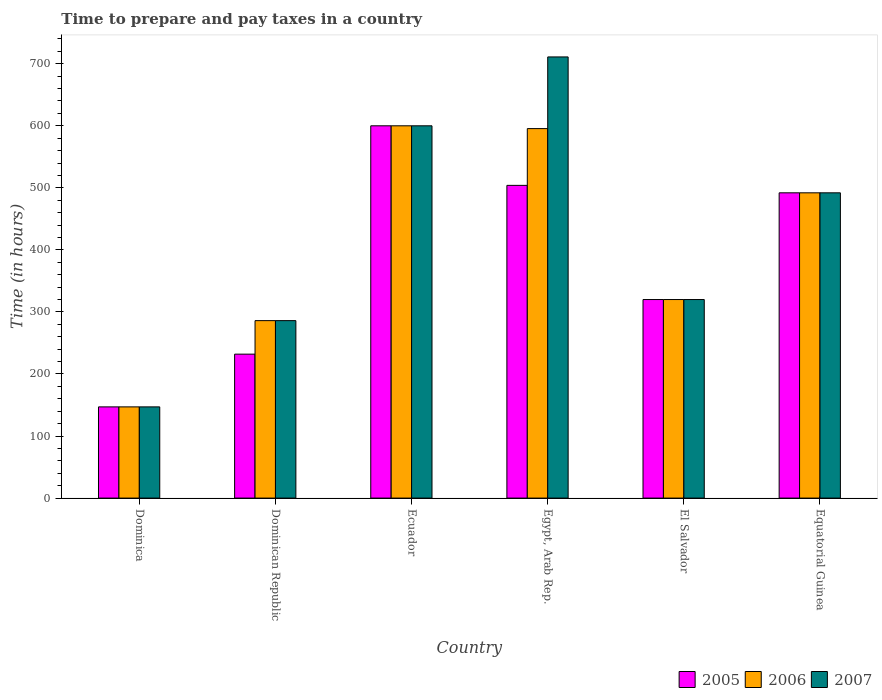How many bars are there on the 1st tick from the left?
Make the answer very short. 3. What is the label of the 6th group of bars from the left?
Offer a terse response. Equatorial Guinea. What is the number of hours required to prepare and pay taxes in 2007 in Egypt, Arab Rep.?
Make the answer very short. 711. Across all countries, what is the maximum number of hours required to prepare and pay taxes in 2005?
Ensure brevity in your answer.  600. Across all countries, what is the minimum number of hours required to prepare and pay taxes in 2005?
Keep it short and to the point. 147. In which country was the number of hours required to prepare and pay taxes in 2007 maximum?
Offer a very short reply. Egypt, Arab Rep. In which country was the number of hours required to prepare and pay taxes in 2007 minimum?
Keep it short and to the point. Dominica. What is the total number of hours required to prepare and pay taxes in 2006 in the graph?
Provide a short and direct response. 2440.5. What is the difference between the number of hours required to prepare and pay taxes in 2005 in Dominica and the number of hours required to prepare and pay taxes in 2007 in Equatorial Guinea?
Your answer should be very brief. -345. What is the average number of hours required to prepare and pay taxes in 2006 per country?
Offer a terse response. 406.75. What is the difference between the number of hours required to prepare and pay taxes of/in 2007 and number of hours required to prepare and pay taxes of/in 2006 in Dominican Republic?
Your answer should be very brief. 0. What is the ratio of the number of hours required to prepare and pay taxes in 2007 in Ecuador to that in El Salvador?
Provide a short and direct response. 1.88. Is the number of hours required to prepare and pay taxes in 2006 in Dominica less than that in Dominican Republic?
Offer a terse response. Yes. What is the difference between the highest and the second highest number of hours required to prepare and pay taxes in 2005?
Your response must be concise. 96. What is the difference between the highest and the lowest number of hours required to prepare and pay taxes in 2006?
Your response must be concise. 453. Is the sum of the number of hours required to prepare and pay taxes in 2007 in Dominica and Egypt, Arab Rep. greater than the maximum number of hours required to prepare and pay taxes in 2005 across all countries?
Keep it short and to the point. Yes. What does the 3rd bar from the right in Ecuador represents?
Offer a terse response. 2005. How many bars are there?
Your answer should be compact. 18. What is the difference between two consecutive major ticks on the Y-axis?
Give a very brief answer. 100. Are the values on the major ticks of Y-axis written in scientific E-notation?
Offer a terse response. No. Does the graph contain any zero values?
Keep it short and to the point. No. Does the graph contain grids?
Your answer should be very brief. No. Where does the legend appear in the graph?
Give a very brief answer. Bottom right. How many legend labels are there?
Your response must be concise. 3. How are the legend labels stacked?
Provide a succinct answer. Horizontal. What is the title of the graph?
Offer a terse response. Time to prepare and pay taxes in a country. What is the label or title of the Y-axis?
Ensure brevity in your answer.  Time (in hours). What is the Time (in hours) in 2005 in Dominica?
Offer a very short reply. 147. What is the Time (in hours) of 2006 in Dominica?
Ensure brevity in your answer.  147. What is the Time (in hours) of 2007 in Dominica?
Provide a succinct answer. 147. What is the Time (in hours) in 2005 in Dominican Republic?
Offer a terse response. 232. What is the Time (in hours) of 2006 in Dominican Republic?
Your answer should be very brief. 286. What is the Time (in hours) of 2007 in Dominican Republic?
Provide a succinct answer. 286. What is the Time (in hours) of 2005 in Ecuador?
Make the answer very short. 600. What is the Time (in hours) in 2006 in Ecuador?
Keep it short and to the point. 600. What is the Time (in hours) in 2007 in Ecuador?
Your answer should be compact. 600. What is the Time (in hours) in 2005 in Egypt, Arab Rep.?
Ensure brevity in your answer.  504. What is the Time (in hours) in 2006 in Egypt, Arab Rep.?
Make the answer very short. 595.5. What is the Time (in hours) of 2007 in Egypt, Arab Rep.?
Provide a succinct answer. 711. What is the Time (in hours) of 2005 in El Salvador?
Provide a succinct answer. 320. What is the Time (in hours) in 2006 in El Salvador?
Ensure brevity in your answer.  320. What is the Time (in hours) of 2007 in El Salvador?
Make the answer very short. 320. What is the Time (in hours) in 2005 in Equatorial Guinea?
Make the answer very short. 492. What is the Time (in hours) of 2006 in Equatorial Guinea?
Your response must be concise. 492. What is the Time (in hours) in 2007 in Equatorial Guinea?
Ensure brevity in your answer.  492. Across all countries, what is the maximum Time (in hours) in 2005?
Provide a short and direct response. 600. Across all countries, what is the maximum Time (in hours) of 2006?
Offer a very short reply. 600. Across all countries, what is the maximum Time (in hours) of 2007?
Offer a terse response. 711. Across all countries, what is the minimum Time (in hours) of 2005?
Keep it short and to the point. 147. Across all countries, what is the minimum Time (in hours) in 2006?
Your answer should be compact. 147. Across all countries, what is the minimum Time (in hours) in 2007?
Your answer should be compact. 147. What is the total Time (in hours) of 2005 in the graph?
Make the answer very short. 2295. What is the total Time (in hours) of 2006 in the graph?
Your answer should be compact. 2440.5. What is the total Time (in hours) of 2007 in the graph?
Offer a terse response. 2556. What is the difference between the Time (in hours) in 2005 in Dominica and that in Dominican Republic?
Offer a very short reply. -85. What is the difference between the Time (in hours) in 2006 in Dominica and that in Dominican Republic?
Provide a succinct answer. -139. What is the difference between the Time (in hours) of 2007 in Dominica and that in Dominican Republic?
Give a very brief answer. -139. What is the difference between the Time (in hours) of 2005 in Dominica and that in Ecuador?
Your answer should be very brief. -453. What is the difference between the Time (in hours) of 2006 in Dominica and that in Ecuador?
Offer a very short reply. -453. What is the difference between the Time (in hours) of 2007 in Dominica and that in Ecuador?
Your answer should be very brief. -453. What is the difference between the Time (in hours) in 2005 in Dominica and that in Egypt, Arab Rep.?
Your response must be concise. -357. What is the difference between the Time (in hours) of 2006 in Dominica and that in Egypt, Arab Rep.?
Your answer should be very brief. -448.5. What is the difference between the Time (in hours) of 2007 in Dominica and that in Egypt, Arab Rep.?
Provide a succinct answer. -564. What is the difference between the Time (in hours) of 2005 in Dominica and that in El Salvador?
Ensure brevity in your answer.  -173. What is the difference between the Time (in hours) in 2006 in Dominica and that in El Salvador?
Make the answer very short. -173. What is the difference between the Time (in hours) in 2007 in Dominica and that in El Salvador?
Ensure brevity in your answer.  -173. What is the difference between the Time (in hours) in 2005 in Dominica and that in Equatorial Guinea?
Keep it short and to the point. -345. What is the difference between the Time (in hours) of 2006 in Dominica and that in Equatorial Guinea?
Provide a succinct answer. -345. What is the difference between the Time (in hours) in 2007 in Dominica and that in Equatorial Guinea?
Give a very brief answer. -345. What is the difference between the Time (in hours) of 2005 in Dominican Republic and that in Ecuador?
Keep it short and to the point. -368. What is the difference between the Time (in hours) in 2006 in Dominican Republic and that in Ecuador?
Your answer should be compact. -314. What is the difference between the Time (in hours) of 2007 in Dominican Republic and that in Ecuador?
Make the answer very short. -314. What is the difference between the Time (in hours) of 2005 in Dominican Republic and that in Egypt, Arab Rep.?
Give a very brief answer. -272. What is the difference between the Time (in hours) of 2006 in Dominican Republic and that in Egypt, Arab Rep.?
Make the answer very short. -309.5. What is the difference between the Time (in hours) of 2007 in Dominican Republic and that in Egypt, Arab Rep.?
Keep it short and to the point. -425. What is the difference between the Time (in hours) of 2005 in Dominican Republic and that in El Salvador?
Offer a terse response. -88. What is the difference between the Time (in hours) of 2006 in Dominican Republic and that in El Salvador?
Ensure brevity in your answer.  -34. What is the difference between the Time (in hours) of 2007 in Dominican Republic and that in El Salvador?
Provide a short and direct response. -34. What is the difference between the Time (in hours) in 2005 in Dominican Republic and that in Equatorial Guinea?
Ensure brevity in your answer.  -260. What is the difference between the Time (in hours) in 2006 in Dominican Republic and that in Equatorial Guinea?
Your answer should be compact. -206. What is the difference between the Time (in hours) in 2007 in Dominican Republic and that in Equatorial Guinea?
Make the answer very short. -206. What is the difference between the Time (in hours) in 2005 in Ecuador and that in Egypt, Arab Rep.?
Your answer should be very brief. 96. What is the difference between the Time (in hours) in 2006 in Ecuador and that in Egypt, Arab Rep.?
Provide a succinct answer. 4.5. What is the difference between the Time (in hours) of 2007 in Ecuador and that in Egypt, Arab Rep.?
Your answer should be very brief. -111. What is the difference between the Time (in hours) in 2005 in Ecuador and that in El Salvador?
Provide a succinct answer. 280. What is the difference between the Time (in hours) of 2006 in Ecuador and that in El Salvador?
Provide a succinct answer. 280. What is the difference between the Time (in hours) in 2007 in Ecuador and that in El Salvador?
Keep it short and to the point. 280. What is the difference between the Time (in hours) of 2005 in Ecuador and that in Equatorial Guinea?
Your answer should be compact. 108. What is the difference between the Time (in hours) in 2006 in Ecuador and that in Equatorial Guinea?
Offer a very short reply. 108. What is the difference between the Time (in hours) of 2007 in Ecuador and that in Equatorial Guinea?
Give a very brief answer. 108. What is the difference between the Time (in hours) of 2005 in Egypt, Arab Rep. and that in El Salvador?
Your answer should be compact. 184. What is the difference between the Time (in hours) of 2006 in Egypt, Arab Rep. and that in El Salvador?
Provide a short and direct response. 275.5. What is the difference between the Time (in hours) of 2007 in Egypt, Arab Rep. and that in El Salvador?
Offer a very short reply. 391. What is the difference between the Time (in hours) of 2005 in Egypt, Arab Rep. and that in Equatorial Guinea?
Your response must be concise. 12. What is the difference between the Time (in hours) in 2006 in Egypt, Arab Rep. and that in Equatorial Guinea?
Your answer should be compact. 103.5. What is the difference between the Time (in hours) in 2007 in Egypt, Arab Rep. and that in Equatorial Guinea?
Keep it short and to the point. 219. What is the difference between the Time (in hours) in 2005 in El Salvador and that in Equatorial Guinea?
Offer a very short reply. -172. What is the difference between the Time (in hours) in 2006 in El Salvador and that in Equatorial Guinea?
Provide a succinct answer. -172. What is the difference between the Time (in hours) of 2007 in El Salvador and that in Equatorial Guinea?
Provide a succinct answer. -172. What is the difference between the Time (in hours) in 2005 in Dominica and the Time (in hours) in 2006 in Dominican Republic?
Your answer should be very brief. -139. What is the difference between the Time (in hours) of 2005 in Dominica and the Time (in hours) of 2007 in Dominican Republic?
Provide a succinct answer. -139. What is the difference between the Time (in hours) of 2006 in Dominica and the Time (in hours) of 2007 in Dominican Republic?
Ensure brevity in your answer.  -139. What is the difference between the Time (in hours) in 2005 in Dominica and the Time (in hours) in 2006 in Ecuador?
Keep it short and to the point. -453. What is the difference between the Time (in hours) in 2005 in Dominica and the Time (in hours) in 2007 in Ecuador?
Provide a succinct answer. -453. What is the difference between the Time (in hours) in 2006 in Dominica and the Time (in hours) in 2007 in Ecuador?
Your answer should be compact. -453. What is the difference between the Time (in hours) in 2005 in Dominica and the Time (in hours) in 2006 in Egypt, Arab Rep.?
Offer a terse response. -448.5. What is the difference between the Time (in hours) in 2005 in Dominica and the Time (in hours) in 2007 in Egypt, Arab Rep.?
Offer a very short reply. -564. What is the difference between the Time (in hours) in 2006 in Dominica and the Time (in hours) in 2007 in Egypt, Arab Rep.?
Provide a short and direct response. -564. What is the difference between the Time (in hours) of 2005 in Dominica and the Time (in hours) of 2006 in El Salvador?
Provide a short and direct response. -173. What is the difference between the Time (in hours) in 2005 in Dominica and the Time (in hours) in 2007 in El Salvador?
Offer a very short reply. -173. What is the difference between the Time (in hours) of 2006 in Dominica and the Time (in hours) of 2007 in El Salvador?
Your answer should be compact. -173. What is the difference between the Time (in hours) of 2005 in Dominica and the Time (in hours) of 2006 in Equatorial Guinea?
Your answer should be compact. -345. What is the difference between the Time (in hours) in 2005 in Dominica and the Time (in hours) in 2007 in Equatorial Guinea?
Keep it short and to the point. -345. What is the difference between the Time (in hours) of 2006 in Dominica and the Time (in hours) of 2007 in Equatorial Guinea?
Your answer should be very brief. -345. What is the difference between the Time (in hours) of 2005 in Dominican Republic and the Time (in hours) of 2006 in Ecuador?
Offer a very short reply. -368. What is the difference between the Time (in hours) in 2005 in Dominican Republic and the Time (in hours) in 2007 in Ecuador?
Your answer should be compact. -368. What is the difference between the Time (in hours) in 2006 in Dominican Republic and the Time (in hours) in 2007 in Ecuador?
Your answer should be very brief. -314. What is the difference between the Time (in hours) of 2005 in Dominican Republic and the Time (in hours) of 2006 in Egypt, Arab Rep.?
Offer a terse response. -363.5. What is the difference between the Time (in hours) in 2005 in Dominican Republic and the Time (in hours) in 2007 in Egypt, Arab Rep.?
Your answer should be very brief. -479. What is the difference between the Time (in hours) of 2006 in Dominican Republic and the Time (in hours) of 2007 in Egypt, Arab Rep.?
Make the answer very short. -425. What is the difference between the Time (in hours) of 2005 in Dominican Republic and the Time (in hours) of 2006 in El Salvador?
Make the answer very short. -88. What is the difference between the Time (in hours) in 2005 in Dominican Republic and the Time (in hours) in 2007 in El Salvador?
Give a very brief answer. -88. What is the difference between the Time (in hours) in 2006 in Dominican Republic and the Time (in hours) in 2007 in El Salvador?
Your response must be concise. -34. What is the difference between the Time (in hours) in 2005 in Dominican Republic and the Time (in hours) in 2006 in Equatorial Guinea?
Keep it short and to the point. -260. What is the difference between the Time (in hours) in 2005 in Dominican Republic and the Time (in hours) in 2007 in Equatorial Guinea?
Provide a short and direct response. -260. What is the difference between the Time (in hours) of 2006 in Dominican Republic and the Time (in hours) of 2007 in Equatorial Guinea?
Keep it short and to the point. -206. What is the difference between the Time (in hours) in 2005 in Ecuador and the Time (in hours) in 2007 in Egypt, Arab Rep.?
Your response must be concise. -111. What is the difference between the Time (in hours) of 2006 in Ecuador and the Time (in hours) of 2007 in Egypt, Arab Rep.?
Provide a succinct answer. -111. What is the difference between the Time (in hours) in 2005 in Ecuador and the Time (in hours) in 2006 in El Salvador?
Your answer should be compact. 280. What is the difference between the Time (in hours) of 2005 in Ecuador and the Time (in hours) of 2007 in El Salvador?
Provide a succinct answer. 280. What is the difference between the Time (in hours) in 2006 in Ecuador and the Time (in hours) in 2007 in El Salvador?
Ensure brevity in your answer.  280. What is the difference between the Time (in hours) of 2005 in Ecuador and the Time (in hours) of 2006 in Equatorial Guinea?
Provide a short and direct response. 108. What is the difference between the Time (in hours) of 2005 in Ecuador and the Time (in hours) of 2007 in Equatorial Guinea?
Keep it short and to the point. 108. What is the difference between the Time (in hours) in 2006 in Ecuador and the Time (in hours) in 2007 in Equatorial Guinea?
Ensure brevity in your answer.  108. What is the difference between the Time (in hours) in 2005 in Egypt, Arab Rep. and the Time (in hours) in 2006 in El Salvador?
Provide a short and direct response. 184. What is the difference between the Time (in hours) in 2005 in Egypt, Arab Rep. and the Time (in hours) in 2007 in El Salvador?
Make the answer very short. 184. What is the difference between the Time (in hours) in 2006 in Egypt, Arab Rep. and the Time (in hours) in 2007 in El Salvador?
Keep it short and to the point. 275.5. What is the difference between the Time (in hours) of 2006 in Egypt, Arab Rep. and the Time (in hours) of 2007 in Equatorial Guinea?
Give a very brief answer. 103.5. What is the difference between the Time (in hours) in 2005 in El Salvador and the Time (in hours) in 2006 in Equatorial Guinea?
Provide a succinct answer. -172. What is the difference between the Time (in hours) of 2005 in El Salvador and the Time (in hours) of 2007 in Equatorial Guinea?
Offer a very short reply. -172. What is the difference between the Time (in hours) in 2006 in El Salvador and the Time (in hours) in 2007 in Equatorial Guinea?
Your response must be concise. -172. What is the average Time (in hours) of 2005 per country?
Provide a succinct answer. 382.5. What is the average Time (in hours) of 2006 per country?
Your answer should be very brief. 406.75. What is the average Time (in hours) in 2007 per country?
Give a very brief answer. 426. What is the difference between the Time (in hours) of 2006 and Time (in hours) of 2007 in Dominica?
Ensure brevity in your answer.  0. What is the difference between the Time (in hours) of 2005 and Time (in hours) of 2006 in Dominican Republic?
Give a very brief answer. -54. What is the difference between the Time (in hours) of 2005 and Time (in hours) of 2007 in Dominican Republic?
Ensure brevity in your answer.  -54. What is the difference between the Time (in hours) in 2006 and Time (in hours) in 2007 in Dominican Republic?
Provide a succinct answer. 0. What is the difference between the Time (in hours) in 2005 and Time (in hours) in 2006 in Ecuador?
Provide a succinct answer. 0. What is the difference between the Time (in hours) in 2006 and Time (in hours) in 2007 in Ecuador?
Ensure brevity in your answer.  0. What is the difference between the Time (in hours) of 2005 and Time (in hours) of 2006 in Egypt, Arab Rep.?
Provide a short and direct response. -91.5. What is the difference between the Time (in hours) in 2005 and Time (in hours) in 2007 in Egypt, Arab Rep.?
Keep it short and to the point. -207. What is the difference between the Time (in hours) of 2006 and Time (in hours) of 2007 in Egypt, Arab Rep.?
Provide a short and direct response. -115.5. What is the difference between the Time (in hours) of 2005 and Time (in hours) of 2006 in El Salvador?
Your answer should be compact. 0. What is the difference between the Time (in hours) in 2006 and Time (in hours) in 2007 in El Salvador?
Your answer should be very brief. 0. What is the difference between the Time (in hours) of 2005 and Time (in hours) of 2006 in Equatorial Guinea?
Offer a very short reply. 0. What is the difference between the Time (in hours) in 2006 and Time (in hours) in 2007 in Equatorial Guinea?
Provide a short and direct response. 0. What is the ratio of the Time (in hours) of 2005 in Dominica to that in Dominican Republic?
Provide a succinct answer. 0.63. What is the ratio of the Time (in hours) of 2006 in Dominica to that in Dominican Republic?
Offer a terse response. 0.51. What is the ratio of the Time (in hours) of 2007 in Dominica to that in Dominican Republic?
Provide a succinct answer. 0.51. What is the ratio of the Time (in hours) in 2005 in Dominica to that in Ecuador?
Your answer should be compact. 0.24. What is the ratio of the Time (in hours) of 2006 in Dominica to that in Ecuador?
Make the answer very short. 0.24. What is the ratio of the Time (in hours) in 2007 in Dominica to that in Ecuador?
Give a very brief answer. 0.24. What is the ratio of the Time (in hours) in 2005 in Dominica to that in Egypt, Arab Rep.?
Give a very brief answer. 0.29. What is the ratio of the Time (in hours) of 2006 in Dominica to that in Egypt, Arab Rep.?
Offer a terse response. 0.25. What is the ratio of the Time (in hours) of 2007 in Dominica to that in Egypt, Arab Rep.?
Your answer should be very brief. 0.21. What is the ratio of the Time (in hours) of 2005 in Dominica to that in El Salvador?
Give a very brief answer. 0.46. What is the ratio of the Time (in hours) in 2006 in Dominica to that in El Salvador?
Make the answer very short. 0.46. What is the ratio of the Time (in hours) in 2007 in Dominica to that in El Salvador?
Make the answer very short. 0.46. What is the ratio of the Time (in hours) of 2005 in Dominica to that in Equatorial Guinea?
Offer a very short reply. 0.3. What is the ratio of the Time (in hours) in 2006 in Dominica to that in Equatorial Guinea?
Offer a very short reply. 0.3. What is the ratio of the Time (in hours) in 2007 in Dominica to that in Equatorial Guinea?
Your answer should be compact. 0.3. What is the ratio of the Time (in hours) in 2005 in Dominican Republic to that in Ecuador?
Your answer should be very brief. 0.39. What is the ratio of the Time (in hours) in 2006 in Dominican Republic to that in Ecuador?
Make the answer very short. 0.48. What is the ratio of the Time (in hours) in 2007 in Dominican Republic to that in Ecuador?
Your answer should be very brief. 0.48. What is the ratio of the Time (in hours) of 2005 in Dominican Republic to that in Egypt, Arab Rep.?
Provide a short and direct response. 0.46. What is the ratio of the Time (in hours) in 2006 in Dominican Republic to that in Egypt, Arab Rep.?
Ensure brevity in your answer.  0.48. What is the ratio of the Time (in hours) in 2007 in Dominican Republic to that in Egypt, Arab Rep.?
Provide a short and direct response. 0.4. What is the ratio of the Time (in hours) of 2005 in Dominican Republic to that in El Salvador?
Offer a terse response. 0.72. What is the ratio of the Time (in hours) of 2006 in Dominican Republic to that in El Salvador?
Offer a very short reply. 0.89. What is the ratio of the Time (in hours) in 2007 in Dominican Republic to that in El Salvador?
Provide a succinct answer. 0.89. What is the ratio of the Time (in hours) of 2005 in Dominican Republic to that in Equatorial Guinea?
Your answer should be very brief. 0.47. What is the ratio of the Time (in hours) in 2006 in Dominican Republic to that in Equatorial Guinea?
Make the answer very short. 0.58. What is the ratio of the Time (in hours) of 2007 in Dominican Republic to that in Equatorial Guinea?
Give a very brief answer. 0.58. What is the ratio of the Time (in hours) in 2005 in Ecuador to that in Egypt, Arab Rep.?
Your answer should be compact. 1.19. What is the ratio of the Time (in hours) of 2006 in Ecuador to that in Egypt, Arab Rep.?
Ensure brevity in your answer.  1.01. What is the ratio of the Time (in hours) in 2007 in Ecuador to that in Egypt, Arab Rep.?
Your answer should be very brief. 0.84. What is the ratio of the Time (in hours) of 2005 in Ecuador to that in El Salvador?
Your response must be concise. 1.88. What is the ratio of the Time (in hours) of 2006 in Ecuador to that in El Salvador?
Offer a terse response. 1.88. What is the ratio of the Time (in hours) of 2007 in Ecuador to that in El Salvador?
Provide a succinct answer. 1.88. What is the ratio of the Time (in hours) in 2005 in Ecuador to that in Equatorial Guinea?
Your answer should be compact. 1.22. What is the ratio of the Time (in hours) in 2006 in Ecuador to that in Equatorial Guinea?
Provide a succinct answer. 1.22. What is the ratio of the Time (in hours) in 2007 in Ecuador to that in Equatorial Guinea?
Your answer should be compact. 1.22. What is the ratio of the Time (in hours) of 2005 in Egypt, Arab Rep. to that in El Salvador?
Offer a very short reply. 1.57. What is the ratio of the Time (in hours) in 2006 in Egypt, Arab Rep. to that in El Salvador?
Keep it short and to the point. 1.86. What is the ratio of the Time (in hours) of 2007 in Egypt, Arab Rep. to that in El Salvador?
Offer a very short reply. 2.22. What is the ratio of the Time (in hours) in 2005 in Egypt, Arab Rep. to that in Equatorial Guinea?
Make the answer very short. 1.02. What is the ratio of the Time (in hours) of 2006 in Egypt, Arab Rep. to that in Equatorial Guinea?
Provide a succinct answer. 1.21. What is the ratio of the Time (in hours) of 2007 in Egypt, Arab Rep. to that in Equatorial Guinea?
Offer a terse response. 1.45. What is the ratio of the Time (in hours) of 2005 in El Salvador to that in Equatorial Guinea?
Make the answer very short. 0.65. What is the ratio of the Time (in hours) of 2006 in El Salvador to that in Equatorial Guinea?
Your answer should be compact. 0.65. What is the ratio of the Time (in hours) of 2007 in El Salvador to that in Equatorial Guinea?
Your answer should be compact. 0.65. What is the difference between the highest and the second highest Time (in hours) in 2005?
Your answer should be very brief. 96. What is the difference between the highest and the second highest Time (in hours) in 2006?
Your response must be concise. 4.5. What is the difference between the highest and the second highest Time (in hours) in 2007?
Ensure brevity in your answer.  111. What is the difference between the highest and the lowest Time (in hours) of 2005?
Your response must be concise. 453. What is the difference between the highest and the lowest Time (in hours) in 2006?
Give a very brief answer. 453. What is the difference between the highest and the lowest Time (in hours) of 2007?
Your answer should be compact. 564. 